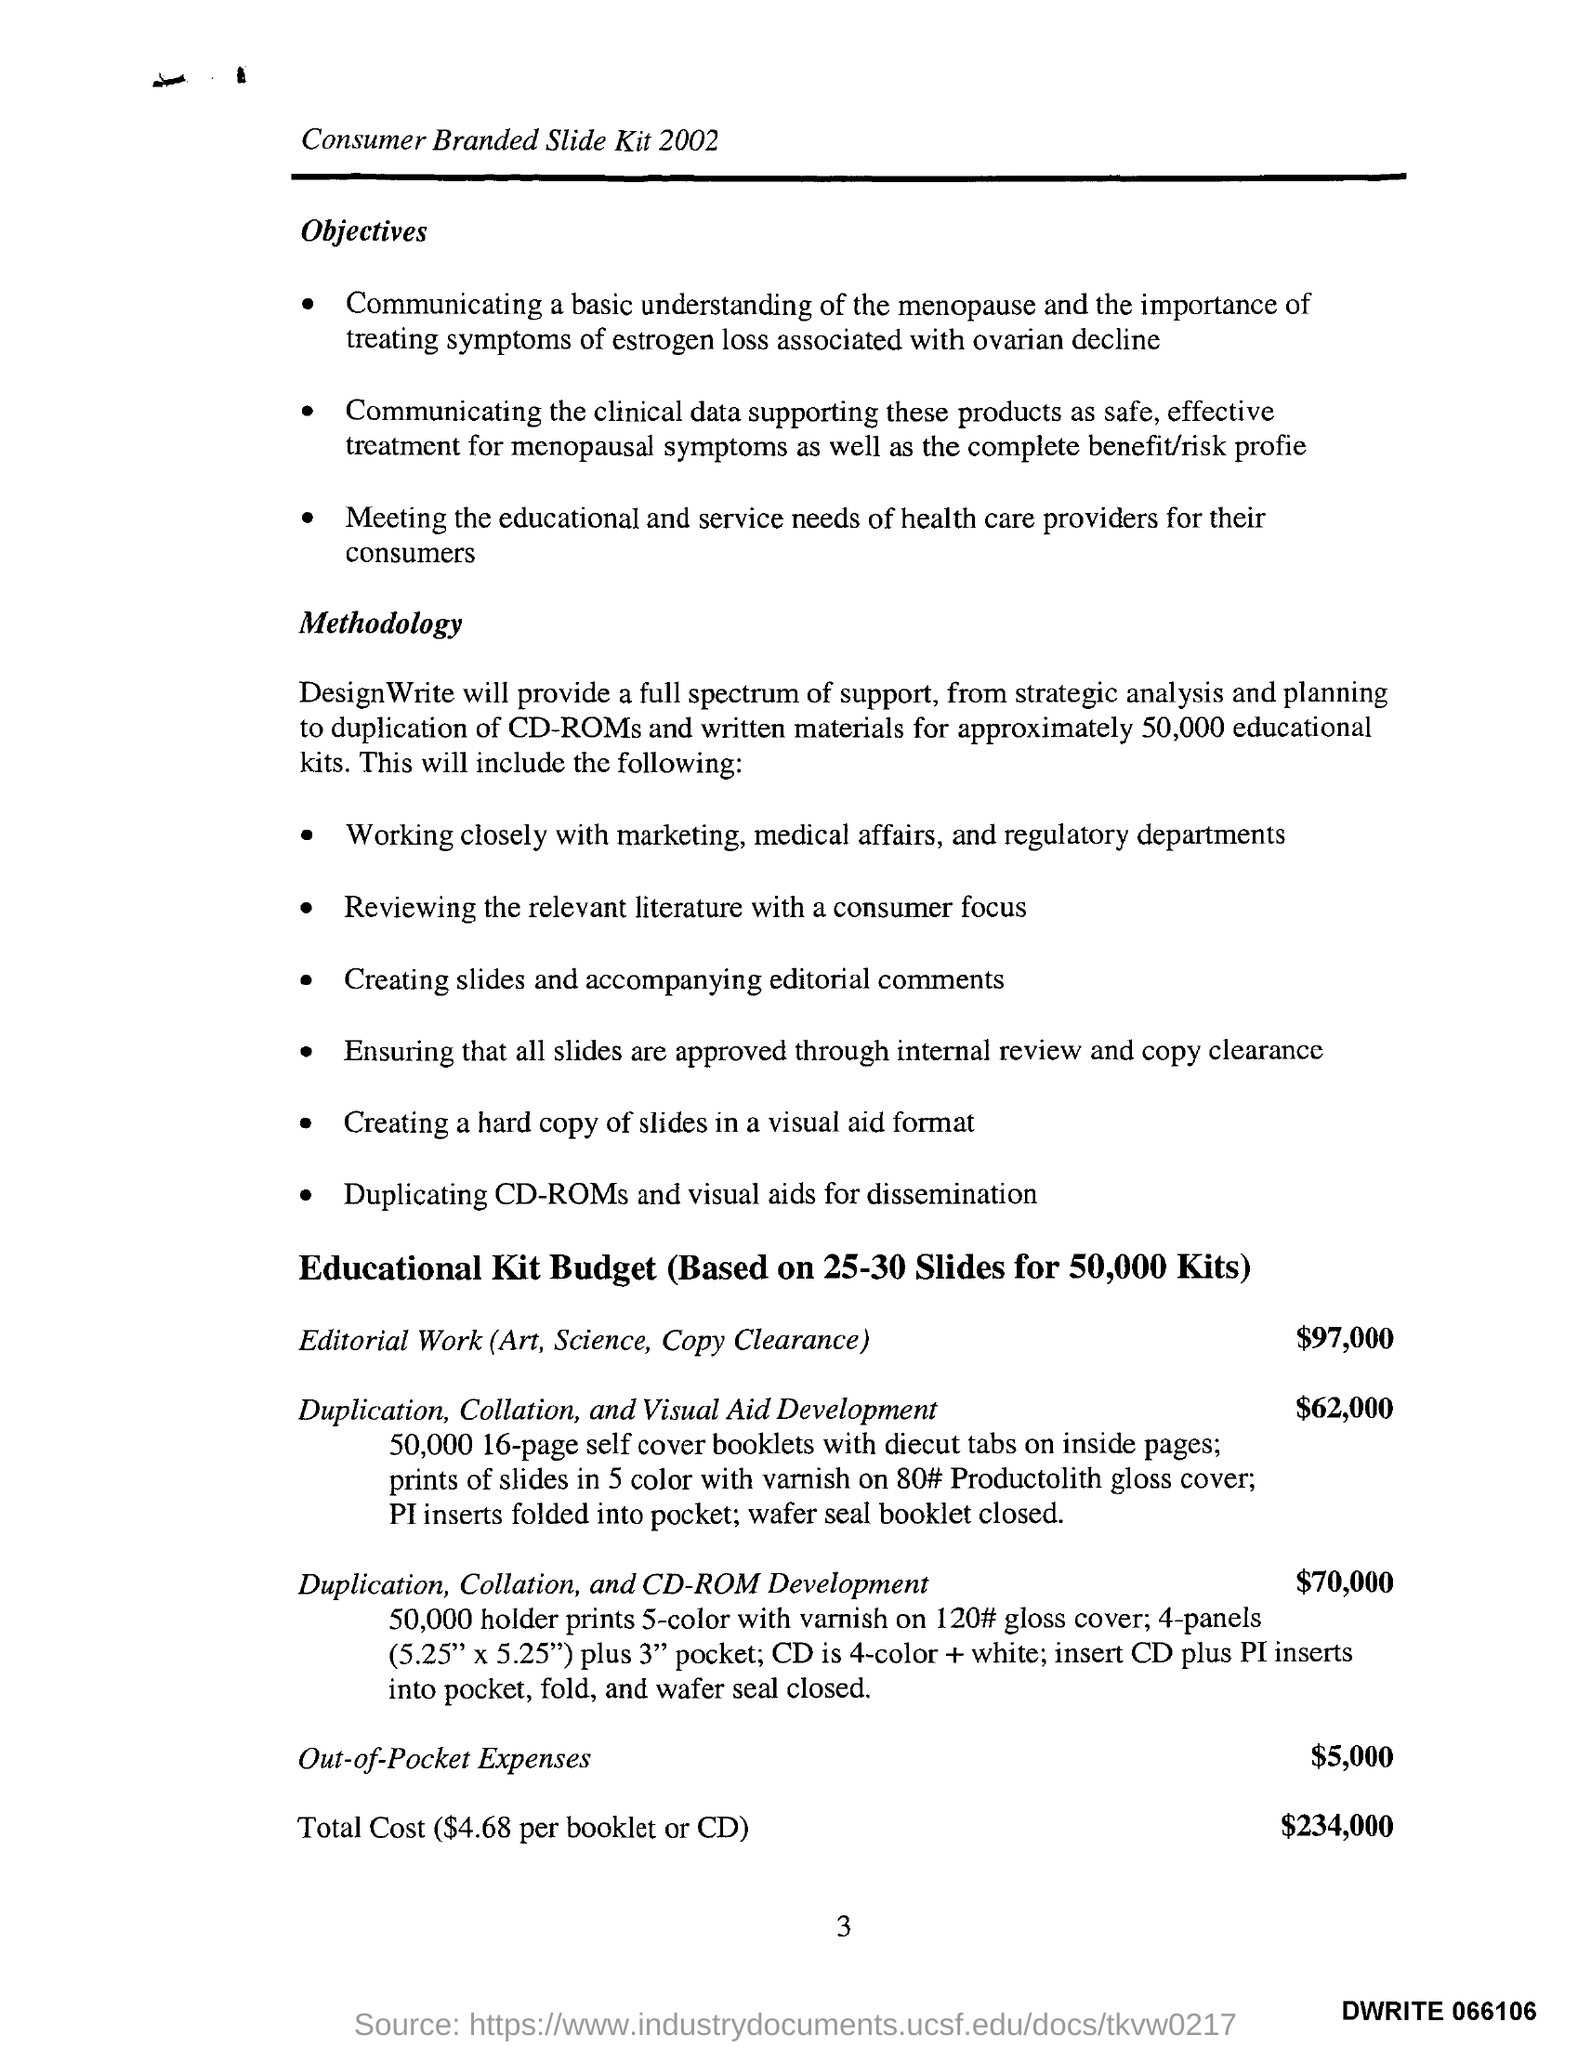What is the Page Number?
Provide a short and direct response. 3. What is the total cost?
Make the answer very short. $234,000. What is the out-of-pocket expense?
Offer a very short reply. $5,000. What is the budget for editorial work?
Offer a very short reply. $ 97,000. 